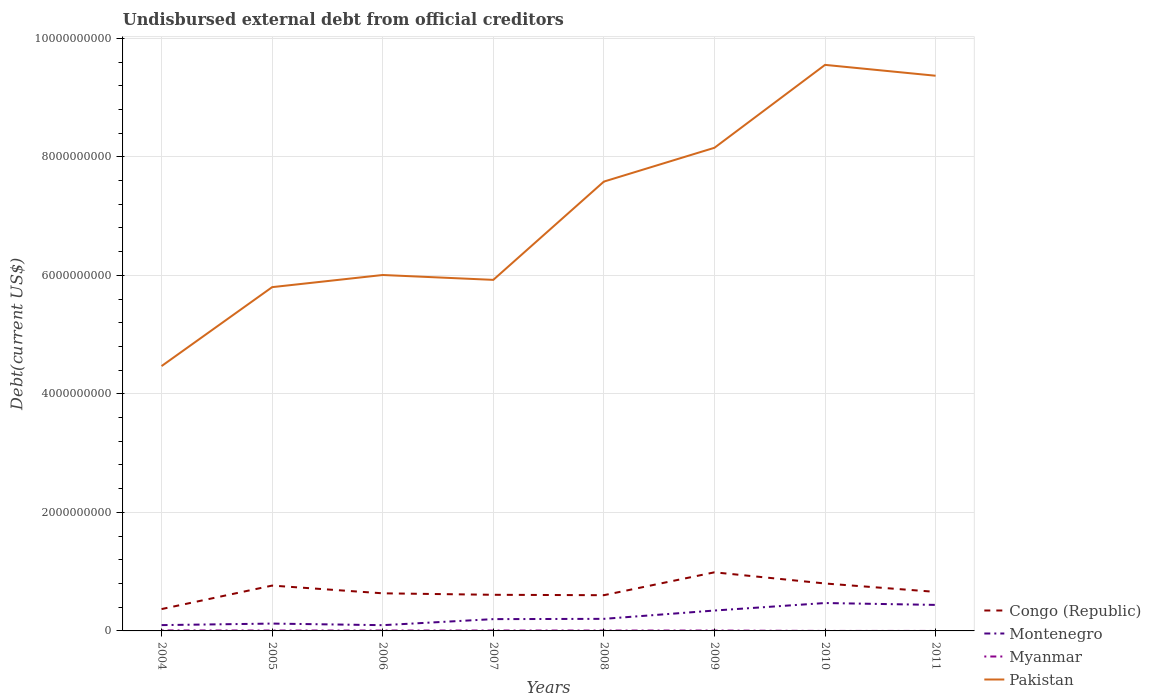How many different coloured lines are there?
Make the answer very short. 4. Is the number of lines equal to the number of legend labels?
Offer a terse response. Yes. Across all years, what is the maximum total debt in Montenegro?
Your answer should be very brief. 9.70e+07. In which year was the total debt in Myanmar maximum?
Make the answer very short. 2010. What is the total total debt in Pakistan in the graph?
Make the answer very short. -3.44e+09. What is the difference between the highest and the second highest total debt in Pakistan?
Make the answer very short. 5.08e+09. What is the difference between the highest and the lowest total debt in Myanmar?
Offer a terse response. 6. Is the total debt in Myanmar strictly greater than the total debt in Montenegro over the years?
Ensure brevity in your answer.  Yes. How many years are there in the graph?
Give a very brief answer. 8. What is the difference between two consecutive major ticks on the Y-axis?
Make the answer very short. 2.00e+09. How many legend labels are there?
Keep it short and to the point. 4. What is the title of the graph?
Your answer should be very brief. Undisbursed external debt from official creditors. Does "Dominican Republic" appear as one of the legend labels in the graph?
Ensure brevity in your answer.  No. What is the label or title of the X-axis?
Provide a short and direct response. Years. What is the label or title of the Y-axis?
Keep it short and to the point. Debt(current US$). What is the Debt(current US$) in Congo (Republic) in 2004?
Offer a very short reply. 3.69e+08. What is the Debt(current US$) of Montenegro in 2004?
Keep it short and to the point. 9.81e+07. What is the Debt(current US$) of Myanmar in 2004?
Make the answer very short. 8.59e+06. What is the Debt(current US$) of Pakistan in 2004?
Give a very brief answer. 4.47e+09. What is the Debt(current US$) in Congo (Republic) in 2005?
Your response must be concise. 7.65e+08. What is the Debt(current US$) of Montenegro in 2005?
Make the answer very short. 1.24e+08. What is the Debt(current US$) of Myanmar in 2005?
Ensure brevity in your answer.  6.80e+06. What is the Debt(current US$) in Pakistan in 2005?
Keep it short and to the point. 5.80e+09. What is the Debt(current US$) of Congo (Republic) in 2006?
Make the answer very short. 6.35e+08. What is the Debt(current US$) in Montenegro in 2006?
Provide a short and direct response. 9.70e+07. What is the Debt(current US$) of Myanmar in 2006?
Your response must be concise. 6.84e+06. What is the Debt(current US$) of Pakistan in 2006?
Your response must be concise. 6.01e+09. What is the Debt(current US$) of Congo (Republic) in 2007?
Provide a short and direct response. 6.10e+08. What is the Debt(current US$) of Montenegro in 2007?
Your response must be concise. 1.99e+08. What is the Debt(current US$) in Myanmar in 2007?
Offer a terse response. 6.80e+06. What is the Debt(current US$) in Pakistan in 2007?
Keep it short and to the point. 5.92e+09. What is the Debt(current US$) in Congo (Republic) in 2008?
Your answer should be very brief. 6.03e+08. What is the Debt(current US$) of Montenegro in 2008?
Your answer should be compact. 2.04e+08. What is the Debt(current US$) of Myanmar in 2008?
Your answer should be compact. 6.31e+06. What is the Debt(current US$) in Pakistan in 2008?
Keep it short and to the point. 7.58e+09. What is the Debt(current US$) in Congo (Republic) in 2009?
Your response must be concise. 9.89e+08. What is the Debt(current US$) in Montenegro in 2009?
Keep it short and to the point. 3.44e+08. What is the Debt(current US$) in Myanmar in 2009?
Give a very brief answer. 6.37e+06. What is the Debt(current US$) in Pakistan in 2009?
Ensure brevity in your answer.  8.15e+09. What is the Debt(current US$) of Congo (Republic) in 2010?
Offer a terse response. 8.00e+08. What is the Debt(current US$) in Montenegro in 2010?
Ensure brevity in your answer.  4.71e+08. What is the Debt(current US$) of Myanmar in 2010?
Ensure brevity in your answer.  2.10e+04. What is the Debt(current US$) of Pakistan in 2010?
Your answer should be compact. 9.55e+09. What is the Debt(current US$) in Congo (Republic) in 2011?
Provide a short and direct response. 6.59e+08. What is the Debt(current US$) in Montenegro in 2011?
Provide a succinct answer. 4.39e+08. What is the Debt(current US$) of Myanmar in 2011?
Keep it short and to the point. 2.10e+04. What is the Debt(current US$) of Pakistan in 2011?
Offer a terse response. 9.37e+09. Across all years, what is the maximum Debt(current US$) of Congo (Republic)?
Give a very brief answer. 9.89e+08. Across all years, what is the maximum Debt(current US$) in Montenegro?
Your answer should be compact. 4.71e+08. Across all years, what is the maximum Debt(current US$) in Myanmar?
Your response must be concise. 8.59e+06. Across all years, what is the maximum Debt(current US$) of Pakistan?
Your answer should be compact. 9.55e+09. Across all years, what is the minimum Debt(current US$) in Congo (Republic)?
Provide a short and direct response. 3.69e+08. Across all years, what is the minimum Debt(current US$) in Montenegro?
Offer a very short reply. 9.70e+07. Across all years, what is the minimum Debt(current US$) in Myanmar?
Your answer should be compact. 2.10e+04. Across all years, what is the minimum Debt(current US$) of Pakistan?
Provide a succinct answer. 4.47e+09. What is the total Debt(current US$) of Congo (Republic) in the graph?
Keep it short and to the point. 5.43e+09. What is the total Debt(current US$) in Montenegro in the graph?
Offer a very short reply. 1.98e+09. What is the total Debt(current US$) in Myanmar in the graph?
Make the answer very short. 4.18e+07. What is the total Debt(current US$) of Pakistan in the graph?
Your answer should be compact. 5.69e+1. What is the difference between the Debt(current US$) of Congo (Republic) in 2004 and that in 2005?
Keep it short and to the point. -3.96e+08. What is the difference between the Debt(current US$) in Montenegro in 2004 and that in 2005?
Keep it short and to the point. -2.58e+07. What is the difference between the Debt(current US$) of Myanmar in 2004 and that in 2005?
Provide a succinct answer. 1.79e+06. What is the difference between the Debt(current US$) of Pakistan in 2004 and that in 2005?
Offer a terse response. -1.33e+09. What is the difference between the Debt(current US$) in Congo (Republic) in 2004 and that in 2006?
Provide a succinct answer. -2.66e+08. What is the difference between the Debt(current US$) in Montenegro in 2004 and that in 2006?
Provide a succinct answer. 1.08e+06. What is the difference between the Debt(current US$) in Myanmar in 2004 and that in 2006?
Offer a very short reply. 1.75e+06. What is the difference between the Debt(current US$) in Pakistan in 2004 and that in 2006?
Provide a succinct answer. -1.54e+09. What is the difference between the Debt(current US$) in Congo (Republic) in 2004 and that in 2007?
Provide a short and direct response. -2.41e+08. What is the difference between the Debt(current US$) of Montenegro in 2004 and that in 2007?
Provide a succinct answer. -1.01e+08. What is the difference between the Debt(current US$) of Myanmar in 2004 and that in 2007?
Keep it short and to the point. 1.80e+06. What is the difference between the Debt(current US$) of Pakistan in 2004 and that in 2007?
Offer a very short reply. -1.45e+09. What is the difference between the Debt(current US$) of Congo (Republic) in 2004 and that in 2008?
Make the answer very short. -2.34e+08. What is the difference between the Debt(current US$) of Montenegro in 2004 and that in 2008?
Make the answer very short. -1.06e+08. What is the difference between the Debt(current US$) of Myanmar in 2004 and that in 2008?
Your answer should be compact. 2.28e+06. What is the difference between the Debt(current US$) in Pakistan in 2004 and that in 2008?
Ensure brevity in your answer.  -3.11e+09. What is the difference between the Debt(current US$) of Congo (Republic) in 2004 and that in 2009?
Your answer should be very brief. -6.20e+08. What is the difference between the Debt(current US$) in Montenegro in 2004 and that in 2009?
Ensure brevity in your answer.  -2.46e+08. What is the difference between the Debt(current US$) in Myanmar in 2004 and that in 2009?
Provide a succinct answer. 2.23e+06. What is the difference between the Debt(current US$) in Pakistan in 2004 and that in 2009?
Keep it short and to the point. -3.68e+09. What is the difference between the Debt(current US$) of Congo (Republic) in 2004 and that in 2010?
Offer a terse response. -4.32e+08. What is the difference between the Debt(current US$) of Montenegro in 2004 and that in 2010?
Your answer should be compact. -3.73e+08. What is the difference between the Debt(current US$) in Myanmar in 2004 and that in 2010?
Offer a terse response. 8.57e+06. What is the difference between the Debt(current US$) in Pakistan in 2004 and that in 2010?
Offer a very short reply. -5.08e+09. What is the difference between the Debt(current US$) of Congo (Republic) in 2004 and that in 2011?
Offer a very short reply. -2.90e+08. What is the difference between the Debt(current US$) in Montenegro in 2004 and that in 2011?
Provide a short and direct response. -3.41e+08. What is the difference between the Debt(current US$) in Myanmar in 2004 and that in 2011?
Provide a succinct answer. 8.57e+06. What is the difference between the Debt(current US$) in Pakistan in 2004 and that in 2011?
Your answer should be compact. -4.90e+09. What is the difference between the Debt(current US$) of Congo (Republic) in 2005 and that in 2006?
Provide a short and direct response. 1.31e+08. What is the difference between the Debt(current US$) of Montenegro in 2005 and that in 2006?
Give a very brief answer. 2.69e+07. What is the difference between the Debt(current US$) in Myanmar in 2005 and that in 2006?
Provide a short and direct response. -4.20e+04. What is the difference between the Debt(current US$) in Pakistan in 2005 and that in 2006?
Your answer should be very brief. -2.05e+08. What is the difference between the Debt(current US$) of Congo (Republic) in 2005 and that in 2007?
Provide a succinct answer. 1.55e+08. What is the difference between the Debt(current US$) of Montenegro in 2005 and that in 2007?
Your answer should be compact. -7.52e+07. What is the difference between the Debt(current US$) of Myanmar in 2005 and that in 2007?
Offer a terse response. 8000. What is the difference between the Debt(current US$) of Pakistan in 2005 and that in 2007?
Your response must be concise. -1.23e+08. What is the difference between the Debt(current US$) in Congo (Republic) in 2005 and that in 2008?
Give a very brief answer. 1.62e+08. What is the difference between the Debt(current US$) of Montenegro in 2005 and that in 2008?
Provide a succinct answer. -7.98e+07. What is the difference between the Debt(current US$) of Myanmar in 2005 and that in 2008?
Your answer should be compact. 4.93e+05. What is the difference between the Debt(current US$) of Pakistan in 2005 and that in 2008?
Your answer should be compact. -1.78e+09. What is the difference between the Debt(current US$) of Congo (Republic) in 2005 and that in 2009?
Provide a short and direct response. -2.24e+08. What is the difference between the Debt(current US$) of Montenegro in 2005 and that in 2009?
Ensure brevity in your answer.  -2.20e+08. What is the difference between the Debt(current US$) in Myanmar in 2005 and that in 2009?
Ensure brevity in your answer.  4.37e+05. What is the difference between the Debt(current US$) of Pakistan in 2005 and that in 2009?
Your answer should be very brief. -2.35e+09. What is the difference between the Debt(current US$) in Congo (Republic) in 2005 and that in 2010?
Offer a terse response. -3.54e+07. What is the difference between the Debt(current US$) of Montenegro in 2005 and that in 2010?
Your response must be concise. -3.47e+08. What is the difference between the Debt(current US$) of Myanmar in 2005 and that in 2010?
Your answer should be compact. 6.78e+06. What is the difference between the Debt(current US$) of Pakistan in 2005 and that in 2010?
Your answer should be very brief. -3.75e+09. What is the difference between the Debt(current US$) of Congo (Republic) in 2005 and that in 2011?
Offer a very short reply. 1.06e+08. What is the difference between the Debt(current US$) in Montenegro in 2005 and that in 2011?
Keep it short and to the point. -3.15e+08. What is the difference between the Debt(current US$) in Myanmar in 2005 and that in 2011?
Your response must be concise. 6.78e+06. What is the difference between the Debt(current US$) in Pakistan in 2005 and that in 2011?
Give a very brief answer. -3.57e+09. What is the difference between the Debt(current US$) of Congo (Republic) in 2006 and that in 2007?
Give a very brief answer. 2.50e+07. What is the difference between the Debt(current US$) in Montenegro in 2006 and that in 2007?
Offer a very short reply. -1.02e+08. What is the difference between the Debt(current US$) of Pakistan in 2006 and that in 2007?
Your answer should be compact. 8.21e+07. What is the difference between the Debt(current US$) in Congo (Republic) in 2006 and that in 2008?
Your answer should be very brief. 3.18e+07. What is the difference between the Debt(current US$) in Montenegro in 2006 and that in 2008?
Offer a very short reply. -1.07e+08. What is the difference between the Debt(current US$) in Myanmar in 2006 and that in 2008?
Provide a short and direct response. 5.35e+05. What is the difference between the Debt(current US$) of Pakistan in 2006 and that in 2008?
Give a very brief answer. -1.58e+09. What is the difference between the Debt(current US$) of Congo (Republic) in 2006 and that in 2009?
Offer a terse response. -3.54e+08. What is the difference between the Debt(current US$) of Montenegro in 2006 and that in 2009?
Your answer should be very brief. -2.47e+08. What is the difference between the Debt(current US$) of Myanmar in 2006 and that in 2009?
Offer a very short reply. 4.79e+05. What is the difference between the Debt(current US$) in Pakistan in 2006 and that in 2009?
Provide a short and direct response. -2.15e+09. What is the difference between the Debt(current US$) of Congo (Republic) in 2006 and that in 2010?
Your answer should be compact. -1.66e+08. What is the difference between the Debt(current US$) of Montenegro in 2006 and that in 2010?
Give a very brief answer. -3.74e+08. What is the difference between the Debt(current US$) in Myanmar in 2006 and that in 2010?
Your answer should be very brief. 6.82e+06. What is the difference between the Debt(current US$) in Pakistan in 2006 and that in 2010?
Offer a very short reply. -3.55e+09. What is the difference between the Debt(current US$) in Congo (Republic) in 2006 and that in 2011?
Provide a short and direct response. -2.42e+07. What is the difference between the Debt(current US$) of Montenegro in 2006 and that in 2011?
Offer a very short reply. -3.42e+08. What is the difference between the Debt(current US$) in Myanmar in 2006 and that in 2011?
Provide a short and direct response. 6.82e+06. What is the difference between the Debt(current US$) of Pakistan in 2006 and that in 2011?
Offer a terse response. -3.36e+09. What is the difference between the Debt(current US$) of Congo (Republic) in 2007 and that in 2008?
Make the answer very short. 6.79e+06. What is the difference between the Debt(current US$) in Montenegro in 2007 and that in 2008?
Keep it short and to the point. -4.64e+06. What is the difference between the Debt(current US$) in Myanmar in 2007 and that in 2008?
Provide a succinct answer. 4.85e+05. What is the difference between the Debt(current US$) in Pakistan in 2007 and that in 2008?
Give a very brief answer. -1.66e+09. What is the difference between the Debt(current US$) of Congo (Republic) in 2007 and that in 2009?
Keep it short and to the point. -3.79e+08. What is the difference between the Debt(current US$) of Montenegro in 2007 and that in 2009?
Provide a short and direct response. -1.45e+08. What is the difference between the Debt(current US$) of Myanmar in 2007 and that in 2009?
Provide a short and direct response. 4.29e+05. What is the difference between the Debt(current US$) in Pakistan in 2007 and that in 2009?
Ensure brevity in your answer.  -2.23e+09. What is the difference between the Debt(current US$) in Congo (Republic) in 2007 and that in 2010?
Ensure brevity in your answer.  -1.91e+08. What is the difference between the Debt(current US$) in Montenegro in 2007 and that in 2010?
Keep it short and to the point. -2.72e+08. What is the difference between the Debt(current US$) in Myanmar in 2007 and that in 2010?
Give a very brief answer. 6.77e+06. What is the difference between the Debt(current US$) in Pakistan in 2007 and that in 2010?
Keep it short and to the point. -3.63e+09. What is the difference between the Debt(current US$) in Congo (Republic) in 2007 and that in 2011?
Offer a very short reply. -4.92e+07. What is the difference between the Debt(current US$) in Montenegro in 2007 and that in 2011?
Ensure brevity in your answer.  -2.40e+08. What is the difference between the Debt(current US$) in Myanmar in 2007 and that in 2011?
Your answer should be compact. 6.77e+06. What is the difference between the Debt(current US$) of Pakistan in 2007 and that in 2011?
Ensure brevity in your answer.  -3.44e+09. What is the difference between the Debt(current US$) in Congo (Republic) in 2008 and that in 2009?
Ensure brevity in your answer.  -3.86e+08. What is the difference between the Debt(current US$) in Montenegro in 2008 and that in 2009?
Your answer should be very brief. -1.40e+08. What is the difference between the Debt(current US$) in Myanmar in 2008 and that in 2009?
Keep it short and to the point. -5.60e+04. What is the difference between the Debt(current US$) of Pakistan in 2008 and that in 2009?
Offer a very short reply. -5.70e+08. What is the difference between the Debt(current US$) of Congo (Republic) in 2008 and that in 2010?
Give a very brief answer. -1.98e+08. What is the difference between the Debt(current US$) of Montenegro in 2008 and that in 2010?
Your answer should be compact. -2.67e+08. What is the difference between the Debt(current US$) in Myanmar in 2008 and that in 2010?
Your answer should be very brief. 6.29e+06. What is the difference between the Debt(current US$) of Pakistan in 2008 and that in 2010?
Make the answer very short. -1.97e+09. What is the difference between the Debt(current US$) in Congo (Republic) in 2008 and that in 2011?
Keep it short and to the point. -5.60e+07. What is the difference between the Debt(current US$) in Montenegro in 2008 and that in 2011?
Give a very brief answer. -2.35e+08. What is the difference between the Debt(current US$) of Myanmar in 2008 and that in 2011?
Offer a terse response. 6.29e+06. What is the difference between the Debt(current US$) in Pakistan in 2008 and that in 2011?
Provide a succinct answer. -1.79e+09. What is the difference between the Debt(current US$) of Congo (Republic) in 2009 and that in 2010?
Offer a terse response. 1.89e+08. What is the difference between the Debt(current US$) in Montenegro in 2009 and that in 2010?
Offer a terse response. -1.27e+08. What is the difference between the Debt(current US$) of Myanmar in 2009 and that in 2010?
Your answer should be compact. 6.34e+06. What is the difference between the Debt(current US$) in Pakistan in 2009 and that in 2010?
Keep it short and to the point. -1.40e+09. What is the difference between the Debt(current US$) of Congo (Republic) in 2009 and that in 2011?
Provide a succinct answer. 3.30e+08. What is the difference between the Debt(current US$) in Montenegro in 2009 and that in 2011?
Provide a short and direct response. -9.49e+07. What is the difference between the Debt(current US$) in Myanmar in 2009 and that in 2011?
Ensure brevity in your answer.  6.34e+06. What is the difference between the Debt(current US$) in Pakistan in 2009 and that in 2011?
Your response must be concise. -1.22e+09. What is the difference between the Debt(current US$) in Congo (Republic) in 2010 and that in 2011?
Offer a very short reply. 1.42e+08. What is the difference between the Debt(current US$) in Montenegro in 2010 and that in 2011?
Provide a succinct answer. 3.17e+07. What is the difference between the Debt(current US$) in Pakistan in 2010 and that in 2011?
Your answer should be very brief. 1.83e+08. What is the difference between the Debt(current US$) of Congo (Republic) in 2004 and the Debt(current US$) of Montenegro in 2005?
Keep it short and to the point. 2.45e+08. What is the difference between the Debt(current US$) in Congo (Republic) in 2004 and the Debt(current US$) in Myanmar in 2005?
Your response must be concise. 3.62e+08. What is the difference between the Debt(current US$) in Congo (Republic) in 2004 and the Debt(current US$) in Pakistan in 2005?
Your answer should be very brief. -5.43e+09. What is the difference between the Debt(current US$) in Montenegro in 2004 and the Debt(current US$) in Myanmar in 2005?
Give a very brief answer. 9.13e+07. What is the difference between the Debt(current US$) in Montenegro in 2004 and the Debt(current US$) in Pakistan in 2005?
Keep it short and to the point. -5.70e+09. What is the difference between the Debt(current US$) in Myanmar in 2004 and the Debt(current US$) in Pakistan in 2005?
Your answer should be compact. -5.79e+09. What is the difference between the Debt(current US$) in Congo (Republic) in 2004 and the Debt(current US$) in Montenegro in 2006?
Make the answer very short. 2.72e+08. What is the difference between the Debt(current US$) in Congo (Republic) in 2004 and the Debt(current US$) in Myanmar in 2006?
Provide a succinct answer. 3.62e+08. What is the difference between the Debt(current US$) of Congo (Republic) in 2004 and the Debt(current US$) of Pakistan in 2006?
Make the answer very short. -5.64e+09. What is the difference between the Debt(current US$) of Montenegro in 2004 and the Debt(current US$) of Myanmar in 2006?
Your answer should be very brief. 9.12e+07. What is the difference between the Debt(current US$) of Montenegro in 2004 and the Debt(current US$) of Pakistan in 2006?
Offer a terse response. -5.91e+09. What is the difference between the Debt(current US$) of Myanmar in 2004 and the Debt(current US$) of Pakistan in 2006?
Give a very brief answer. -6.00e+09. What is the difference between the Debt(current US$) in Congo (Republic) in 2004 and the Debt(current US$) in Montenegro in 2007?
Ensure brevity in your answer.  1.70e+08. What is the difference between the Debt(current US$) in Congo (Republic) in 2004 and the Debt(current US$) in Myanmar in 2007?
Offer a very short reply. 3.62e+08. What is the difference between the Debt(current US$) of Congo (Republic) in 2004 and the Debt(current US$) of Pakistan in 2007?
Give a very brief answer. -5.56e+09. What is the difference between the Debt(current US$) in Montenegro in 2004 and the Debt(current US$) in Myanmar in 2007?
Ensure brevity in your answer.  9.13e+07. What is the difference between the Debt(current US$) of Montenegro in 2004 and the Debt(current US$) of Pakistan in 2007?
Give a very brief answer. -5.83e+09. What is the difference between the Debt(current US$) of Myanmar in 2004 and the Debt(current US$) of Pakistan in 2007?
Offer a very short reply. -5.92e+09. What is the difference between the Debt(current US$) of Congo (Republic) in 2004 and the Debt(current US$) of Montenegro in 2008?
Give a very brief answer. 1.65e+08. What is the difference between the Debt(current US$) of Congo (Republic) in 2004 and the Debt(current US$) of Myanmar in 2008?
Your response must be concise. 3.62e+08. What is the difference between the Debt(current US$) of Congo (Republic) in 2004 and the Debt(current US$) of Pakistan in 2008?
Your response must be concise. -7.21e+09. What is the difference between the Debt(current US$) of Montenegro in 2004 and the Debt(current US$) of Myanmar in 2008?
Ensure brevity in your answer.  9.18e+07. What is the difference between the Debt(current US$) of Montenegro in 2004 and the Debt(current US$) of Pakistan in 2008?
Provide a short and direct response. -7.48e+09. What is the difference between the Debt(current US$) of Myanmar in 2004 and the Debt(current US$) of Pakistan in 2008?
Provide a short and direct response. -7.57e+09. What is the difference between the Debt(current US$) of Congo (Republic) in 2004 and the Debt(current US$) of Montenegro in 2009?
Your answer should be compact. 2.47e+07. What is the difference between the Debt(current US$) in Congo (Republic) in 2004 and the Debt(current US$) in Myanmar in 2009?
Your answer should be compact. 3.62e+08. What is the difference between the Debt(current US$) of Congo (Republic) in 2004 and the Debt(current US$) of Pakistan in 2009?
Keep it short and to the point. -7.78e+09. What is the difference between the Debt(current US$) of Montenegro in 2004 and the Debt(current US$) of Myanmar in 2009?
Make the answer very short. 9.17e+07. What is the difference between the Debt(current US$) in Montenegro in 2004 and the Debt(current US$) in Pakistan in 2009?
Give a very brief answer. -8.05e+09. What is the difference between the Debt(current US$) of Myanmar in 2004 and the Debt(current US$) of Pakistan in 2009?
Provide a short and direct response. -8.14e+09. What is the difference between the Debt(current US$) of Congo (Republic) in 2004 and the Debt(current US$) of Montenegro in 2010?
Make the answer very short. -1.02e+08. What is the difference between the Debt(current US$) in Congo (Republic) in 2004 and the Debt(current US$) in Myanmar in 2010?
Your response must be concise. 3.69e+08. What is the difference between the Debt(current US$) of Congo (Republic) in 2004 and the Debt(current US$) of Pakistan in 2010?
Offer a terse response. -9.18e+09. What is the difference between the Debt(current US$) of Montenegro in 2004 and the Debt(current US$) of Myanmar in 2010?
Ensure brevity in your answer.  9.81e+07. What is the difference between the Debt(current US$) in Montenegro in 2004 and the Debt(current US$) in Pakistan in 2010?
Your answer should be compact. -9.45e+09. What is the difference between the Debt(current US$) of Myanmar in 2004 and the Debt(current US$) of Pakistan in 2010?
Ensure brevity in your answer.  -9.54e+09. What is the difference between the Debt(current US$) of Congo (Republic) in 2004 and the Debt(current US$) of Montenegro in 2011?
Provide a short and direct response. -7.02e+07. What is the difference between the Debt(current US$) in Congo (Republic) in 2004 and the Debt(current US$) in Myanmar in 2011?
Give a very brief answer. 3.69e+08. What is the difference between the Debt(current US$) of Congo (Republic) in 2004 and the Debt(current US$) of Pakistan in 2011?
Your response must be concise. -9.00e+09. What is the difference between the Debt(current US$) in Montenegro in 2004 and the Debt(current US$) in Myanmar in 2011?
Provide a succinct answer. 9.81e+07. What is the difference between the Debt(current US$) in Montenegro in 2004 and the Debt(current US$) in Pakistan in 2011?
Keep it short and to the point. -9.27e+09. What is the difference between the Debt(current US$) of Myanmar in 2004 and the Debt(current US$) of Pakistan in 2011?
Your response must be concise. -9.36e+09. What is the difference between the Debt(current US$) of Congo (Republic) in 2005 and the Debt(current US$) of Montenegro in 2006?
Ensure brevity in your answer.  6.68e+08. What is the difference between the Debt(current US$) of Congo (Republic) in 2005 and the Debt(current US$) of Myanmar in 2006?
Provide a succinct answer. 7.58e+08. What is the difference between the Debt(current US$) of Congo (Republic) in 2005 and the Debt(current US$) of Pakistan in 2006?
Offer a very short reply. -5.24e+09. What is the difference between the Debt(current US$) of Montenegro in 2005 and the Debt(current US$) of Myanmar in 2006?
Ensure brevity in your answer.  1.17e+08. What is the difference between the Debt(current US$) in Montenegro in 2005 and the Debt(current US$) in Pakistan in 2006?
Keep it short and to the point. -5.88e+09. What is the difference between the Debt(current US$) in Myanmar in 2005 and the Debt(current US$) in Pakistan in 2006?
Provide a succinct answer. -6.00e+09. What is the difference between the Debt(current US$) in Congo (Republic) in 2005 and the Debt(current US$) in Montenegro in 2007?
Provide a short and direct response. 5.66e+08. What is the difference between the Debt(current US$) of Congo (Republic) in 2005 and the Debt(current US$) of Myanmar in 2007?
Provide a short and direct response. 7.58e+08. What is the difference between the Debt(current US$) of Congo (Republic) in 2005 and the Debt(current US$) of Pakistan in 2007?
Give a very brief answer. -5.16e+09. What is the difference between the Debt(current US$) of Montenegro in 2005 and the Debt(current US$) of Myanmar in 2007?
Provide a short and direct response. 1.17e+08. What is the difference between the Debt(current US$) of Montenegro in 2005 and the Debt(current US$) of Pakistan in 2007?
Give a very brief answer. -5.80e+09. What is the difference between the Debt(current US$) of Myanmar in 2005 and the Debt(current US$) of Pakistan in 2007?
Keep it short and to the point. -5.92e+09. What is the difference between the Debt(current US$) of Congo (Republic) in 2005 and the Debt(current US$) of Montenegro in 2008?
Provide a short and direct response. 5.61e+08. What is the difference between the Debt(current US$) of Congo (Republic) in 2005 and the Debt(current US$) of Myanmar in 2008?
Your response must be concise. 7.59e+08. What is the difference between the Debt(current US$) in Congo (Republic) in 2005 and the Debt(current US$) in Pakistan in 2008?
Offer a terse response. -6.82e+09. What is the difference between the Debt(current US$) of Montenegro in 2005 and the Debt(current US$) of Myanmar in 2008?
Keep it short and to the point. 1.18e+08. What is the difference between the Debt(current US$) in Montenegro in 2005 and the Debt(current US$) in Pakistan in 2008?
Keep it short and to the point. -7.46e+09. What is the difference between the Debt(current US$) of Myanmar in 2005 and the Debt(current US$) of Pakistan in 2008?
Offer a terse response. -7.58e+09. What is the difference between the Debt(current US$) in Congo (Republic) in 2005 and the Debt(current US$) in Montenegro in 2009?
Provide a succinct answer. 4.21e+08. What is the difference between the Debt(current US$) in Congo (Republic) in 2005 and the Debt(current US$) in Myanmar in 2009?
Your answer should be very brief. 7.59e+08. What is the difference between the Debt(current US$) in Congo (Republic) in 2005 and the Debt(current US$) in Pakistan in 2009?
Your answer should be very brief. -7.39e+09. What is the difference between the Debt(current US$) in Montenegro in 2005 and the Debt(current US$) in Myanmar in 2009?
Offer a very short reply. 1.18e+08. What is the difference between the Debt(current US$) of Montenegro in 2005 and the Debt(current US$) of Pakistan in 2009?
Your response must be concise. -8.03e+09. What is the difference between the Debt(current US$) of Myanmar in 2005 and the Debt(current US$) of Pakistan in 2009?
Offer a terse response. -8.15e+09. What is the difference between the Debt(current US$) of Congo (Republic) in 2005 and the Debt(current US$) of Montenegro in 2010?
Offer a very short reply. 2.94e+08. What is the difference between the Debt(current US$) of Congo (Republic) in 2005 and the Debt(current US$) of Myanmar in 2010?
Your answer should be very brief. 7.65e+08. What is the difference between the Debt(current US$) in Congo (Republic) in 2005 and the Debt(current US$) in Pakistan in 2010?
Make the answer very short. -8.79e+09. What is the difference between the Debt(current US$) in Montenegro in 2005 and the Debt(current US$) in Myanmar in 2010?
Make the answer very short. 1.24e+08. What is the difference between the Debt(current US$) of Montenegro in 2005 and the Debt(current US$) of Pakistan in 2010?
Make the answer very short. -9.43e+09. What is the difference between the Debt(current US$) of Myanmar in 2005 and the Debt(current US$) of Pakistan in 2010?
Provide a short and direct response. -9.54e+09. What is the difference between the Debt(current US$) in Congo (Republic) in 2005 and the Debt(current US$) in Montenegro in 2011?
Give a very brief answer. 3.26e+08. What is the difference between the Debt(current US$) in Congo (Republic) in 2005 and the Debt(current US$) in Myanmar in 2011?
Provide a succinct answer. 7.65e+08. What is the difference between the Debt(current US$) of Congo (Republic) in 2005 and the Debt(current US$) of Pakistan in 2011?
Make the answer very short. -8.60e+09. What is the difference between the Debt(current US$) of Montenegro in 2005 and the Debt(current US$) of Myanmar in 2011?
Your response must be concise. 1.24e+08. What is the difference between the Debt(current US$) in Montenegro in 2005 and the Debt(current US$) in Pakistan in 2011?
Your response must be concise. -9.24e+09. What is the difference between the Debt(current US$) in Myanmar in 2005 and the Debt(current US$) in Pakistan in 2011?
Offer a very short reply. -9.36e+09. What is the difference between the Debt(current US$) in Congo (Republic) in 2006 and the Debt(current US$) in Montenegro in 2007?
Provide a succinct answer. 4.35e+08. What is the difference between the Debt(current US$) in Congo (Republic) in 2006 and the Debt(current US$) in Myanmar in 2007?
Keep it short and to the point. 6.28e+08. What is the difference between the Debt(current US$) of Congo (Republic) in 2006 and the Debt(current US$) of Pakistan in 2007?
Keep it short and to the point. -5.29e+09. What is the difference between the Debt(current US$) of Montenegro in 2006 and the Debt(current US$) of Myanmar in 2007?
Ensure brevity in your answer.  9.02e+07. What is the difference between the Debt(current US$) of Montenegro in 2006 and the Debt(current US$) of Pakistan in 2007?
Make the answer very short. -5.83e+09. What is the difference between the Debt(current US$) of Myanmar in 2006 and the Debt(current US$) of Pakistan in 2007?
Give a very brief answer. -5.92e+09. What is the difference between the Debt(current US$) of Congo (Republic) in 2006 and the Debt(current US$) of Montenegro in 2008?
Ensure brevity in your answer.  4.31e+08. What is the difference between the Debt(current US$) of Congo (Republic) in 2006 and the Debt(current US$) of Myanmar in 2008?
Offer a terse response. 6.28e+08. What is the difference between the Debt(current US$) of Congo (Republic) in 2006 and the Debt(current US$) of Pakistan in 2008?
Give a very brief answer. -6.95e+09. What is the difference between the Debt(current US$) of Montenegro in 2006 and the Debt(current US$) of Myanmar in 2008?
Offer a terse response. 9.07e+07. What is the difference between the Debt(current US$) in Montenegro in 2006 and the Debt(current US$) in Pakistan in 2008?
Offer a terse response. -7.49e+09. What is the difference between the Debt(current US$) in Myanmar in 2006 and the Debt(current US$) in Pakistan in 2008?
Keep it short and to the point. -7.58e+09. What is the difference between the Debt(current US$) of Congo (Republic) in 2006 and the Debt(current US$) of Montenegro in 2009?
Offer a terse response. 2.90e+08. What is the difference between the Debt(current US$) in Congo (Republic) in 2006 and the Debt(current US$) in Myanmar in 2009?
Your response must be concise. 6.28e+08. What is the difference between the Debt(current US$) in Congo (Republic) in 2006 and the Debt(current US$) in Pakistan in 2009?
Keep it short and to the point. -7.52e+09. What is the difference between the Debt(current US$) in Montenegro in 2006 and the Debt(current US$) in Myanmar in 2009?
Ensure brevity in your answer.  9.07e+07. What is the difference between the Debt(current US$) in Montenegro in 2006 and the Debt(current US$) in Pakistan in 2009?
Give a very brief answer. -8.06e+09. What is the difference between the Debt(current US$) in Myanmar in 2006 and the Debt(current US$) in Pakistan in 2009?
Your answer should be compact. -8.15e+09. What is the difference between the Debt(current US$) of Congo (Republic) in 2006 and the Debt(current US$) of Montenegro in 2010?
Offer a terse response. 1.64e+08. What is the difference between the Debt(current US$) of Congo (Republic) in 2006 and the Debt(current US$) of Myanmar in 2010?
Your answer should be very brief. 6.34e+08. What is the difference between the Debt(current US$) of Congo (Republic) in 2006 and the Debt(current US$) of Pakistan in 2010?
Give a very brief answer. -8.92e+09. What is the difference between the Debt(current US$) in Montenegro in 2006 and the Debt(current US$) in Myanmar in 2010?
Your answer should be compact. 9.70e+07. What is the difference between the Debt(current US$) in Montenegro in 2006 and the Debt(current US$) in Pakistan in 2010?
Keep it short and to the point. -9.45e+09. What is the difference between the Debt(current US$) of Myanmar in 2006 and the Debt(current US$) of Pakistan in 2010?
Ensure brevity in your answer.  -9.54e+09. What is the difference between the Debt(current US$) of Congo (Republic) in 2006 and the Debt(current US$) of Montenegro in 2011?
Make the answer very short. 1.96e+08. What is the difference between the Debt(current US$) of Congo (Republic) in 2006 and the Debt(current US$) of Myanmar in 2011?
Offer a very short reply. 6.34e+08. What is the difference between the Debt(current US$) of Congo (Republic) in 2006 and the Debt(current US$) of Pakistan in 2011?
Your answer should be compact. -8.73e+09. What is the difference between the Debt(current US$) in Montenegro in 2006 and the Debt(current US$) in Myanmar in 2011?
Provide a short and direct response. 9.70e+07. What is the difference between the Debt(current US$) of Montenegro in 2006 and the Debt(current US$) of Pakistan in 2011?
Make the answer very short. -9.27e+09. What is the difference between the Debt(current US$) in Myanmar in 2006 and the Debt(current US$) in Pakistan in 2011?
Offer a very short reply. -9.36e+09. What is the difference between the Debt(current US$) in Congo (Republic) in 2007 and the Debt(current US$) in Montenegro in 2008?
Your answer should be compact. 4.06e+08. What is the difference between the Debt(current US$) in Congo (Republic) in 2007 and the Debt(current US$) in Myanmar in 2008?
Your answer should be compact. 6.03e+08. What is the difference between the Debt(current US$) in Congo (Republic) in 2007 and the Debt(current US$) in Pakistan in 2008?
Make the answer very short. -6.97e+09. What is the difference between the Debt(current US$) in Montenegro in 2007 and the Debt(current US$) in Myanmar in 2008?
Your response must be concise. 1.93e+08. What is the difference between the Debt(current US$) of Montenegro in 2007 and the Debt(current US$) of Pakistan in 2008?
Your answer should be very brief. -7.38e+09. What is the difference between the Debt(current US$) of Myanmar in 2007 and the Debt(current US$) of Pakistan in 2008?
Provide a succinct answer. -7.58e+09. What is the difference between the Debt(current US$) in Congo (Republic) in 2007 and the Debt(current US$) in Montenegro in 2009?
Offer a terse response. 2.66e+08. What is the difference between the Debt(current US$) of Congo (Republic) in 2007 and the Debt(current US$) of Myanmar in 2009?
Offer a very short reply. 6.03e+08. What is the difference between the Debt(current US$) of Congo (Republic) in 2007 and the Debt(current US$) of Pakistan in 2009?
Offer a very short reply. -7.54e+09. What is the difference between the Debt(current US$) in Montenegro in 2007 and the Debt(current US$) in Myanmar in 2009?
Your response must be concise. 1.93e+08. What is the difference between the Debt(current US$) in Montenegro in 2007 and the Debt(current US$) in Pakistan in 2009?
Give a very brief answer. -7.95e+09. What is the difference between the Debt(current US$) of Myanmar in 2007 and the Debt(current US$) of Pakistan in 2009?
Your answer should be very brief. -8.15e+09. What is the difference between the Debt(current US$) in Congo (Republic) in 2007 and the Debt(current US$) in Montenegro in 2010?
Make the answer very short. 1.39e+08. What is the difference between the Debt(current US$) of Congo (Republic) in 2007 and the Debt(current US$) of Myanmar in 2010?
Offer a terse response. 6.10e+08. What is the difference between the Debt(current US$) in Congo (Republic) in 2007 and the Debt(current US$) in Pakistan in 2010?
Your answer should be compact. -8.94e+09. What is the difference between the Debt(current US$) of Montenegro in 2007 and the Debt(current US$) of Myanmar in 2010?
Make the answer very short. 1.99e+08. What is the difference between the Debt(current US$) of Montenegro in 2007 and the Debt(current US$) of Pakistan in 2010?
Give a very brief answer. -9.35e+09. What is the difference between the Debt(current US$) of Myanmar in 2007 and the Debt(current US$) of Pakistan in 2010?
Make the answer very short. -9.54e+09. What is the difference between the Debt(current US$) in Congo (Republic) in 2007 and the Debt(current US$) in Montenegro in 2011?
Offer a terse response. 1.71e+08. What is the difference between the Debt(current US$) of Congo (Republic) in 2007 and the Debt(current US$) of Myanmar in 2011?
Ensure brevity in your answer.  6.10e+08. What is the difference between the Debt(current US$) in Congo (Republic) in 2007 and the Debt(current US$) in Pakistan in 2011?
Ensure brevity in your answer.  -8.76e+09. What is the difference between the Debt(current US$) in Montenegro in 2007 and the Debt(current US$) in Myanmar in 2011?
Ensure brevity in your answer.  1.99e+08. What is the difference between the Debt(current US$) of Montenegro in 2007 and the Debt(current US$) of Pakistan in 2011?
Your response must be concise. -9.17e+09. What is the difference between the Debt(current US$) in Myanmar in 2007 and the Debt(current US$) in Pakistan in 2011?
Keep it short and to the point. -9.36e+09. What is the difference between the Debt(current US$) in Congo (Republic) in 2008 and the Debt(current US$) in Montenegro in 2009?
Your response must be concise. 2.59e+08. What is the difference between the Debt(current US$) in Congo (Republic) in 2008 and the Debt(current US$) in Myanmar in 2009?
Give a very brief answer. 5.96e+08. What is the difference between the Debt(current US$) in Congo (Republic) in 2008 and the Debt(current US$) in Pakistan in 2009?
Offer a terse response. -7.55e+09. What is the difference between the Debt(current US$) in Montenegro in 2008 and the Debt(current US$) in Myanmar in 2009?
Your response must be concise. 1.97e+08. What is the difference between the Debt(current US$) in Montenegro in 2008 and the Debt(current US$) in Pakistan in 2009?
Provide a succinct answer. -7.95e+09. What is the difference between the Debt(current US$) in Myanmar in 2008 and the Debt(current US$) in Pakistan in 2009?
Provide a succinct answer. -8.15e+09. What is the difference between the Debt(current US$) of Congo (Republic) in 2008 and the Debt(current US$) of Montenegro in 2010?
Ensure brevity in your answer.  1.32e+08. What is the difference between the Debt(current US$) of Congo (Republic) in 2008 and the Debt(current US$) of Myanmar in 2010?
Your response must be concise. 6.03e+08. What is the difference between the Debt(current US$) of Congo (Republic) in 2008 and the Debt(current US$) of Pakistan in 2010?
Your answer should be compact. -8.95e+09. What is the difference between the Debt(current US$) in Montenegro in 2008 and the Debt(current US$) in Myanmar in 2010?
Provide a succinct answer. 2.04e+08. What is the difference between the Debt(current US$) in Montenegro in 2008 and the Debt(current US$) in Pakistan in 2010?
Make the answer very short. -9.35e+09. What is the difference between the Debt(current US$) in Myanmar in 2008 and the Debt(current US$) in Pakistan in 2010?
Give a very brief answer. -9.55e+09. What is the difference between the Debt(current US$) in Congo (Republic) in 2008 and the Debt(current US$) in Montenegro in 2011?
Provide a succinct answer. 1.64e+08. What is the difference between the Debt(current US$) of Congo (Republic) in 2008 and the Debt(current US$) of Myanmar in 2011?
Offer a terse response. 6.03e+08. What is the difference between the Debt(current US$) of Congo (Republic) in 2008 and the Debt(current US$) of Pakistan in 2011?
Your answer should be very brief. -8.77e+09. What is the difference between the Debt(current US$) in Montenegro in 2008 and the Debt(current US$) in Myanmar in 2011?
Give a very brief answer. 2.04e+08. What is the difference between the Debt(current US$) of Montenegro in 2008 and the Debt(current US$) of Pakistan in 2011?
Offer a very short reply. -9.16e+09. What is the difference between the Debt(current US$) of Myanmar in 2008 and the Debt(current US$) of Pakistan in 2011?
Provide a short and direct response. -9.36e+09. What is the difference between the Debt(current US$) of Congo (Republic) in 2009 and the Debt(current US$) of Montenegro in 2010?
Keep it short and to the point. 5.18e+08. What is the difference between the Debt(current US$) in Congo (Republic) in 2009 and the Debt(current US$) in Myanmar in 2010?
Provide a short and direct response. 9.89e+08. What is the difference between the Debt(current US$) in Congo (Republic) in 2009 and the Debt(current US$) in Pakistan in 2010?
Your answer should be compact. -8.56e+09. What is the difference between the Debt(current US$) of Montenegro in 2009 and the Debt(current US$) of Myanmar in 2010?
Your answer should be very brief. 3.44e+08. What is the difference between the Debt(current US$) of Montenegro in 2009 and the Debt(current US$) of Pakistan in 2010?
Your answer should be very brief. -9.21e+09. What is the difference between the Debt(current US$) of Myanmar in 2009 and the Debt(current US$) of Pakistan in 2010?
Your answer should be compact. -9.55e+09. What is the difference between the Debt(current US$) of Congo (Republic) in 2009 and the Debt(current US$) of Montenegro in 2011?
Provide a short and direct response. 5.50e+08. What is the difference between the Debt(current US$) in Congo (Republic) in 2009 and the Debt(current US$) in Myanmar in 2011?
Offer a terse response. 9.89e+08. What is the difference between the Debt(current US$) of Congo (Republic) in 2009 and the Debt(current US$) of Pakistan in 2011?
Offer a terse response. -8.38e+09. What is the difference between the Debt(current US$) in Montenegro in 2009 and the Debt(current US$) in Myanmar in 2011?
Ensure brevity in your answer.  3.44e+08. What is the difference between the Debt(current US$) in Montenegro in 2009 and the Debt(current US$) in Pakistan in 2011?
Give a very brief answer. -9.02e+09. What is the difference between the Debt(current US$) in Myanmar in 2009 and the Debt(current US$) in Pakistan in 2011?
Offer a terse response. -9.36e+09. What is the difference between the Debt(current US$) in Congo (Republic) in 2010 and the Debt(current US$) in Montenegro in 2011?
Offer a terse response. 3.61e+08. What is the difference between the Debt(current US$) of Congo (Republic) in 2010 and the Debt(current US$) of Myanmar in 2011?
Offer a very short reply. 8.00e+08. What is the difference between the Debt(current US$) of Congo (Republic) in 2010 and the Debt(current US$) of Pakistan in 2011?
Your answer should be very brief. -8.57e+09. What is the difference between the Debt(current US$) in Montenegro in 2010 and the Debt(current US$) in Myanmar in 2011?
Ensure brevity in your answer.  4.71e+08. What is the difference between the Debt(current US$) of Montenegro in 2010 and the Debt(current US$) of Pakistan in 2011?
Your answer should be very brief. -8.90e+09. What is the difference between the Debt(current US$) in Myanmar in 2010 and the Debt(current US$) in Pakistan in 2011?
Make the answer very short. -9.37e+09. What is the average Debt(current US$) in Congo (Republic) per year?
Offer a terse response. 6.79e+08. What is the average Debt(current US$) in Montenegro per year?
Ensure brevity in your answer.  2.47e+08. What is the average Debt(current US$) in Myanmar per year?
Your answer should be very brief. 5.22e+06. What is the average Debt(current US$) in Pakistan per year?
Provide a short and direct response. 7.11e+09. In the year 2004, what is the difference between the Debt(current US$) of Congo (Republic) and Debt(current US$) of Montenegro?
Ensure brevity in your answer.  2.71e+08. In the year 2004, what is the difference between the Debt(current US$) in Congo (Republic) and Debt(current US$) in Myanmar?
Provide a succinct answer. 3.60e+08. In the year 2004, what is the difference between the Debt(current US$) of Congo (Republic) and Debt(current US$) of Pakistan?
Your response must be concise. -4.10e+09. In the year 2004, what is the difference between the Debt(current US$) of Montenegro and Debt(current US$) of Myanmar?
Make the answer very short. 8.95e+07. In the year 2004, what is the difference between the Debt(current US$) in Montenegro and Debt(current US$) in Pakistan?
Give a very brief answer. -4.37e+09. In the year 2004, what is the difference between the Debt(current US$) in Myanmar and Debt(current US$) in Pakistan?
Give a very brief answer. -4.46e+09. In the year 2005, what is the difference between the Debt(current US$) in Congo (Republic) and Debt(current US$) in Montenegro?
Offer a very short reply. 6.41e+08. In the year 2005, what is the difference between the Debt(current US$) in Congo (Republic) and Debt(current US$) in Myanmar?
Your answer should be compact. 7.58e+08. In the year 2005, what is the difference between the Debt(current US$) of Congo (Republic) and Debt(current US$) of Pakistan?
Give a very brief answer. -5.04e+09. In the year 2005, what is the difference between the Debt(current US$) of Montenegro and Debt(current US$) of Myanmar?
Make the answer very short. 1.17e+08. In the year 2005, what is the difference between the Debt(current US$) in Montenegro and Debt(current US$) in Pakistan?
Your response must be concise. -5.68e+09. In the year 2005, what is the difference between the Debt(current US$) in Myanmar and Debt(current US$) in Pakistan?
Your answer should be compact. -5.79e+09. In the year 2006, what is the difference between the Debt(current US$) in Congo (Republic) and Debt(current US$) in Montenegro?
Keep it short and to the point. 5.38e+08. In the year 2006, what is the difference between the Debt(current US$) of Congo (Republic) and Debt(current US$) of Myanmar?
Ensure brevity in your answer.  6.28e+08. In the year 2006, what is the difference between the Debt(current US$) of Congo (Republic) and Debt(current US$) of Pakistan?
Offer a terse response. -5.37e+09. In the year 2006, what is the difference between the Debt(current US$) of Montenegro and Debt(current US$) of Myanmar?
Provide a short and direct response. 9.02e+07. In the year 2006, what is the difference between the Debt(current US$) of Montenegro and Debt(current US$) of Pakistan?
Ensure brevity in your answer.  -5.91e+09. In the year 2006, what is the difference between the Debt(current US$) of Myanmar and Debt(current US$) of Pakistan?
Your answer should be very brief. -6.00e+09. In the year 2007, what is the difference between the Debt(current US$) in Congo (Republic) and Debt(current US$) in Montenegro?
Make the answer very short. 4.10e+08. In the year 2007, what is the difference between the Debt(current US$) of Congo (Republic) and Debt(current US$) of Myanmar?
Your answer should be compact. 6.03e+08. In the year 2007, what is the difference between the Debt(current US$) in Congo (Republic) and Debt(current US$) in Pakistan?
Your response must be concise. -5.31e+09. In the year 2007, what is the difference between the Debt(current US$) of Montenegro and Debt(current US$) of Myanmar?
Give a very brief answer. 1.92e+08. In the year 2007, what is the difference between the Debt(current US$) in Montenegro and Debt(current US$) in Pakistan?
Your answer should be very brief. -5.72e+09. In the year 2007, what is the difference between the Debt(current US$) in Myanmar and Debt(current US$) in Pakistan?
Provide a succinct answer. -5.92e+09. In the year 2008, what is the difference between the Debt(current US$) in Congo (Republic) and Debt(current US$) in Montenegro?
Offer a very short reply. 3.99e+08. In the year 2008, what is the difference between the Debt(current US$) of Congo (Republic) and Debt(current US$) of Myanmar?
Make the answer very short. 5.96e+08. In the year 2008, what is the difference between the Debt(current US$) of Congo (Republic) and Debt(current US$) of Pakistan?
Give a very brief answer. -6.98e+09. In the year 2008, what is the difference between the Debt(current US$) of Montenegro and Debt(current US$) of Myanmar?
Your answer should be very brief. 1.97e+08. In the year 2008, what is the difference between the Debt(current US$) of Montenegro and Debt(current US$) of Pakistan?
Ensure brevity in your answer.  -7.38e+09. In the year 2008, what is the difference between the Debt(current US$) in Myanmar and Debt(current US$) in Pakistan?
Provide a short and direct response. -7.58e+09. In the year 2009, what is the difference between the Debt(current US$) of Congo (Republic) and Debt(current US$) of Montenegro?
Provide a succinct answer. 6.45e+08. In the year 2009, what is the difference between the Debt(current US$) in Congo (Republic) and Debt(current US$) in Myanmar?
Your answer should be very brief. 9.83e+08. In the year 2009, what is the difference between the Debt(current US$) in Congo (Republic) and Debt(current US$) in Pakistan?
Your answer should be compact. -7.16e+09. In the year 2009, what is the difference between the Debt(current US$) of Montenegro and Debt(current US$) of Myanmar?
Your answer should be compact. 3.38e+08. In the year 2009, what is the difference between the Debt(current US$) in Montenegro and Debt(current US$) in Pakistan?
Give a very brief answer. -7.81e+09. In the year 2009, what is the difference between the Debt(current US$) of Myanmar and Debt(current US$) of Pakistan?
Your answer should be compact. -8.15e+09. In the year 2010, what is the difference between the Debt(current US$) of Congo (Republic) and Debt(current US$) of Montenegro?
Provide a succinct answer. 3.30e+08. In the year 2010, what is the difference between the Debt(current US$) in Congo (Republic) and Debt(current US$) in Myanmar?
Make the answer very short. 8.00e+08. In the year 2010, what is the difference between the Debt(current US$) of Congo (Republic) and Debt(current US$) of Pakistan?
Offer a terse response. -8.75e+09. In the year 2010, what is the difference between the Debt(current US$) in Montenegro and Debt(current US$) in Myanmar?
Ensure brevity in your answer.  4.71e+08. In the year 2010, what is the difference between the Debt(current US$) of Montenegro and Debt(current US$) of Pakistan?
Keep it short and to the point. -9.08e+09. In the year 2010, what is the difference between the Debt(current US$) of Myanmar and Debt(current US$) of Pakistan?
Give a very brief answer. -9.55e+09. In the year 2011, what is the difference between the Debt(current US$) of Congo (Republic) and Debt(current US$) of Montenegro?
Ensure brevity in your answer.  2.20e+08. In the year 2011, what is the difference between the Debt(current US$) of Congo (Republic) and Debt(current US$) of Myanmar?
Your answer should be compact. 6.59e+08. In the year 2011, what is the difference between the Debt(current US$) in Congo (Republic) and Debt(current US$) in Pakistan?
Offer a very short reply. -8.71e+09. In the year 2011, what is the difference between the Debt(current US$) in Montenegro and Debt(current US$) in Myanmar?
Ensure brevity in your answer.  4.39e+08. In the year 2011, what is the difference between the Debt(current US$) of Montenegro and Debt(current US$) of Pakistan?
Make the answer very short. -8.93e+09. In the year 2011, what is the difference between the Debt(current US$) of Myanmar and Debt(current US$) of Pakistan?
Give a very brief answer. -9.37e+09. What is the ratio of the Debt(current US$) of Congo (Republic) in 2004 to that in 2005?
Your answer should be compact. 0.48. What is the ratio of the Debt(current US$) of Montenegro in 2004 to that in 2005?
Your answer should be compact. 0.79. What is the ratio of the Debt(current US$) in Myanmar in 2004 to that in 2005?
Keep it short and to the point. 1.26. What is the ratio of the Debt(current US$) of Pakistan in 2004 to that in 2005?
Provide a succinct answer. 0.77. What is the ratio of the Debt(current US$) in Congo (Republic) in 2004 to that in 2006?
Keep it short and to the point. 0.58. What is the ratio of the Debt(current US$) of Montenegro in 2004 to that in 2006?
Ensure brevity in your answer.  1.01. What is the ratio of the Debt(current US$) of Myanmar in 2004 to that in 2006?
Give a very brief answer. 1.26. What is the ratio of the Debt(current US$) in Pakistan in 2004 to that in 2006?
Give a very brief answer. 0.74. What is the ratio of the Debt(current US$) in Congo (Republic) in 2004 to that in 2007?
Keep it short and to the point. 0.6. What is the ratio of the Debt(current US$) of Montenegro in 2004 to that in 2007?
Offer a very short reply. 0.49. What is the ratio of the Debt(current US$) of Myanmar in 2004 to that in 2007?
Your answer should be very brief. 1.26. What is the ratio of the Debt(current US$) in Pakistan in 2004 to that in 2007?
Your answer should be compact. 0.75. What is the ratio of the Debt(current US$) of Congo (Republic) in 2004 to that in 2008?
Ensure brevity in your answer.  0.61. What is the ratio of the Debt(current US$) of Montenegro in 2004 to that in 2008?
Your answer should be very brief. 0.48. What is the ratio of the Debt(current US$) of Myanmar in 2004 to that in 2008?
Your answer should be very brief. 1.36. What is the ratio of the Debt(current US$) in Pakistan in 2004 to that in 2008?
Provide a succinct answer. 0.59. What is the ratio of the Debt(current US$) in Congo (Republic) in 2004 to that in 2009?
Provide a short and direct response. 0.37. What is the ratio of the Debt(current US$) in Montenegro in 2004 to that in 2009?
Your response must be concise. 0.29. What is the ratio of the Debt(current US$) of Myanmar in 2004 to that in 2009?
Provide a succinct answer. 1.35. What is the ratio of the Debt(current US$) of Pakistan in 2004 to that in 2009?
Make the answer very short. 0.55. What is the ratio of the Debt(current US$) in Congo (Republic) in 2004 to that in 2010?
Provide a short and direct response. 0.46. What is the ratio of the Debt(current US$) in Montenegro in 2004 to that in 2010?
Give a very brief answer. 0.21. What is the ratio of the Debt(current US$) of Myanmar in 2004 to that in 2010?
Your response must be concise. 409.14. What is the ratio of the Debt(current US$) in Pakistan in 2004 to that in 2010?
Offer a terse response. 0.47. What is the ratio of the Debt(current US$) in Congo (Republic) in 2004 to that in 2011?
Your answer should be very brief. 0.56. What is the ratio of the Debt(current US$) in Montenegro in 2004 to that in 2011?
Give a very brief answer. 0.22. What is the ratio of the Debt(current US$) in Myanmar in 2004 to that in 2011?
Make the answer very short. 409.14. What is the ratio of the Debt(current US$) in Pakistan in 2004 to that in 2011?
Keep it short and to the point. 0.48. What is the ratio of the Debt(current US$) in Congo (Republic) in 2005 to that in 2006?
Make the answer very short. 1.21. What is the ratio of the Debt(current US$) of Montenegro in 2005 to that in 2006?
Offer a very short reply. 1.28. What is the ratio of the Debt(current US$) in Myanmar in 2005 to that in 2006?
Ensure brevity in your answer.  0.99. What is the ratio of the Debt(current US$) of Pakistan in 2005 to that in 2006?
Your answer should be compact. 0.97. What is the ratio of the Debt(current US$) in Congo (Republic) in 2005 to that in 2007?
Ensure brevity in your answer.  1.26. What is the ratio of the Debt(current US$) of Montenegro in 2005 to that in 2007?
Provide a short and direct response. 0.62. What is the ratio of the Debt(current US$) of Myanmar in 2005 to that in 2007?
Keep it short and to the point. 1. What is the ratio of the Debt(current US$) of Pakistan in 2005 to that in 2007?
Offer a terse response. 0.98. What is the ratio of the Debt(current US$) of Congo (Republic) in 2005 to that in 2008?
Offer a very short reply. 1.27. What is the ratio of the Debt(current US$) of Montenegro in 2005 to that in 2008?
Offer a terse response. 0.61. What is the ratio of the Debt(current US$) of Myanmar in 2005 to that in 2008?
Offer a terse response. 1.08. What is the ratio of the Debt(current US$) of Pakistan in 2005 to that in 2008?
Offer a very short reply. 0.77. What is the ratio of the Debt(current US$) of Congo (Republic) in 2005 to that in 2009?
Make the answer very short. 0.77. What is the ratio of the Debt(current US$) of Montenegro in 2005 to that in 2009?
Make the answer very short. 0.36. What is the ratio of the Debt(current US$) of Myanmar in 2005 to that in 2009?
Your answer should be very brief. 1.07. What is the ratio of the Debt(current US$) in Pakistan in 2005 to that in 2009?
Provide a short and direct response. 0.71. What is the ratio of the Debt(current US$) of Congo (Republic) in 2005 to that in 2010?
Offer a terse response. 0.96. What is the ratio of the Debt(current US$) of Montenegro in 2005 to that in 2010?
Make the answer very short. 0.26. What is the ratio of the Debt(current US$) of Myanmar in 2005 to that in 2010?
Make the answer very short. 323.95. What is the ratio of the Debt(current US$) of Pakistan in 2005 to that in 2010?
Offer a terse response. 0.61. What is the ratio of the Debt(current US$) of Congo (Republic) in 2005 to that in 2011?
Make the answer very short. 1.16. What is the ratio of the Debt(current US$) in Montenegro in 2005 to that in 2011?
Offer a terse response. 0.28. What is the ratio of the Debt(current US$) in Myanmar in 2005 to that in 2011?
Provide a succinct answer. 323.95. What is the ratio of the Debt(current US$) in Pakistan in 2005 to that in 2011?
Your answer should be compact. 0.62. What is the ratio of the Debt(current US$) in Congo (Republic) in 2006 to that in 2007?
Ensure brevity in your answer.  1.04. What is the ratio of the Debt(current US$) in Montenegro in 2006 to that in 2007?
Ensure brevity in your answer.  0.49. What is the ratio of the Debt(current US$) in Myanmar in 2006 to that in 2007?
Your answer should be compact. 1.01. What is the ratio of the Debt(current US$) in Pakistan in 2006 to that in 2007?
Your answer should be very brief. 1.01. What is the ratio of the Debt(current US$) of Congo (Republic) in 2006 to that in 2008?
Your answer should be compact. 1.05. What is the ratio of the Debt(current US$) of Montenegro in 2006 to that in 2008?
Keep it short and to the point. 0.48. What is the ratio of the Debt(current US$) of Myanmar in 2006 to that in 2008?
Keep it short and to the point. 1.08. What is the ratio of the Debt(current US$) in Pakistan in 2006 to that in 2008?
Provide a succinct answer. 0.79. What is the ratio of the Debt(current US$) of Congo (Republic) in 2006 to that in 2009?
Keep it short and to the point. 0.64. What is the ratio of the Debt(current US$) of Montenegro in 2006 to that in 2009?
Your answer should be compact. 0.28. What is the ratio of the Debt(current US$) in Myanmar in 2006 to that in 2009?
Provide a short and direct response. 1.08. What is the ratio of the Debt(current US$) of Pakistan in 2006 to that in 2009?
Your answer should be compact. 0.74. What is the ratio of the Debt(current US$) in Congo (Republic) in 2006 to that in 2010?
Your response must be concise. 0.79. What is the ratio of the Debt(current US$) in Montenegro in 2006 to that in 2010?
Provide a succinct answer. 0.21. What is the ratio of the Debt(current US$) in Myanmar in 2006 to that in 2010?
Your answer should be compact. 325.95. What is the ratio of the Debt(current US$) of Pakistan in 2006 to that in 2010?
Give a very brief answer. 0.63. What is the ratio of the Debt(current US$) in Congo (Republic) in 2006 to that in 2011?
Keep it short and to the point. 0.96. What is the ratio of the Debt(current US$) in Montenegro in 2006 to that in 2011?
Your response must be concise. 0.22. What is the ratio of the Debt(current US$) in Myanmar in 2006 to that in 2011?
Offer a terse response. 325.95. What is the ratio of the Debt(current US$) in Pakistan in 2006 to that in 2011?
Offer a terse response. 0.64. What is the ratio of the Debt(current US$) of Congo (Republic) in 2007 to that in 2008?
Your answer should be very brief. 1.01. What is the ratio of the Debt(current US$) in Montenegro in 2007 to that in 2008?
Keep it short and to the point. 0.98. What is the ratio of the Debt(current US$) of Pakistan in 2007 to that in 2008?
Make the answer very short. 0.78. What is the ratio of the Debt(current US$) in Congo (Republic) in 2007 to that in 2009?
Your response must be concise. 0.62. What is the ratio of the Debt(current US$) in Montenegro in 2007 to that in 2009?
Your answer should be compact. 0.58. What is the ratio of the Debt(current US$) of Myanmar in 2007 to that in 2009?
Keep it short and to the point. 1.07. What is the ratio of the Debt(current US$) in Pakistan in 2007 to that in 2009?
Your answer should be compact. 0.73. What is the ratio of the Debt(current US$) in Congo (Republic) in 2007 to that in 2010?
Provide a short and direct response. 0.76. What is the ratio of the Debt(current US$) of Montenegro in 2007 to that in 2010?
Keep it short and to the point. 0.42. What is the ratio of the Debt(current US$) of Myanmar in 2007 to that in 2010?
Keep it short and to the point. 323.57. What is the ratio of the Debt(current US$) of Pakistan in 2007 to that in 2010?
Your answer should be very brief. 0.62. What is the ratio of the Debt(current US$) in Congo (Republic) in 2007 to that in 2011?
Give a very brief answer. 0.93. What is the ratio of the Debt(current US$) of Montenegro in 2007 to that in 2011?
Keep it short and to the point. 0.45. What is the ratio of the Debt(current US$) in Myanmar in 2007 to that in 2011?
Ensure brevity in your answer.  323.57. What is the ratio of the Debt(current US$) of Pakistan in 2007 to that in 2011?
Your response must be concise. 0.63. What is the ratio of the Debt(current US$) of Congo (Republic) in 2008 to that in 2009?
Ensure brevity in your answer.  0.61. What is the ratio of the Debt(current US$) of Montenegro in 2008 to that in 2009?
Offer a terse response. 0.59. What is the ratio of the Debt(current US$) in Pakistan in 2008 to that in 2009?
Your response must be concise. 0.93. What is the ratio of the Debt(current US$) in Congo (Republic) in 2008 to that in 2010?
Give a very brief answer. 0.75. What is the ratio of the Debt(current US$) of Montenegro in 2008 to that in 2010?
Provide a succinct answer. 0.43. What is the ratio of the Debt(current US$) of Myanmar in 2008 to that in 2010?
Offer a terse response. 300.48. What is the ratio of the Debt(current US$) in Pakistan in 2008 to that in 2010?
Make the answer very short. 0.79. What is the ratio of the Debt(current US$) of Congo (Republic) in 2008 to that in 2011?
Keep it short and to the point. 0.92. What is the ratio of the Debt(current US$) of Montenegro in 2008 to that in 2011?
Give a very brief answer. 0.46. What is the ratio of the Debt(current US$) of Myanmar in 2008 to that in 2011?
Give a very brief answer. 300.48. What is the ratio of the Debt(current US$) of Pakistan in 2008 to that in 2011?
Your response must be concise. 0.81. What is the ratio of the Debt(current US$) of Congo (Republic) in 2009 to that in 2010?
Offer a very short reply. 1.24. What is the ratio of the Debt(current US$) in Montenegro in 2009 to that in 2010?
Your response must be concise. 0.73. What is the ratio of the Debt(current US$) in Myanmar in 2009 to that in 2010?
Provide a succinct answer. 303.14. What is the ratio of the Debt(current US$) in Pakistan in 2009 to that in 2010?
Provide a succinct answer. 0.85. What is the ratio of the Debt(current US$) of Congo (Republic) in 2009 to that in 2011?
Give a very brief answer. 1.5. What is the ratio of the Debt(current US$) of Montenegro in 2009 to that in 2011?
Make the answer very short. 0.78. What is the ratio of the Debt(current US$) in Myanmar in 2009 to that in 2011?
Make the answer very short. 303.14. What is the ratio of the Debt(current US$) in Pakistan in 2009 to that in 2011?
Provide a succinct answer. 0.87. What is the ratio of the Debt(current US$) of Congo (Republic) in 2010 to that in 2011?
Your answer should be very brief. 1.22. What is the ratio of the Debt(current US$) in Montenegro in 2010 to that in 2011?
Provide a short and direct response. 1.07. What is the ratio of the Debt(current US$) in Pakistan in 2010 to that in 2011?
Your answer should be very brief. 1.02. What is the difference between the highest and the second highest Debt(current US$) of Congo (Republic)?
Keep it short and to the point. 1.89e+08. What is the difference between the highest and the second highest Debt(current US$) in Montenegro?
Your answer should be very brief. 3.17e+07. What is the difference between the highest and the second highest Debt(current US$) in Myanmar?
Provide a succinct answer. 1.75e+06. What is the difference between the highest and the second highest Debt(current US$) in Pakistan?
Provide a succinct answer. 1.83e+08. What is the difference between the highest and the lowest Debt(current US$) in Congo (Republic)?
Your answer should be compact. 6.20e+08. What is the difference between the highest and the lowest Debt(current US$) in Montenegro?
Make the answer very short. 3.74e+08. What is the difference between the highest and the lowest Debt(current US$) in Myanmar?
Offer a terse response. 8.57e+06. What is the difference between the highest and the lowest Debt(current US$) in Pakistan?
Your answer should be compact. 5.08e+09. 